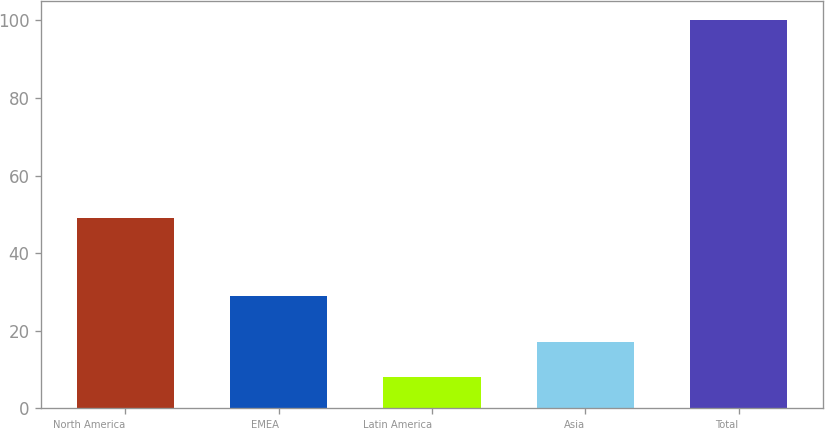<chart> <loc_0><loc_0><loc_500><loc_500><bar_chart><fcel>North America<fcel>EMEA<fcel>Latin America<fcel>Asia<fcel>Total<nl><fcel>49<fcel>29<fcel>8<fcel>17.2<fcel>100<nl></chart> 